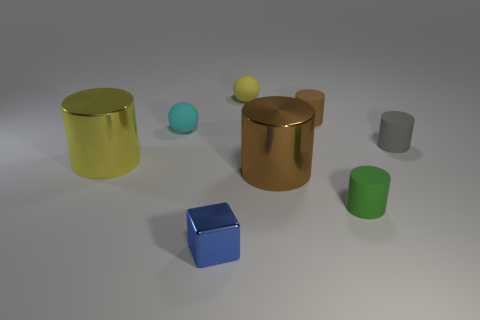How big is the sphere behind the tiny matte cylinder that is on the left side of the matte thing in front of the tiny gray cylinder?
Provide a succinct answer. Small. What size is the cyan ball?
Your response must be concise. Small. Is there a small matte sphere that is behind the big metallic object that is in front of the big shiny object that is left of the yellow ball?
Offer a very short reply. Yes. How many tiny things are either yellow matte balls or cyan objects?
Offer a terse response. 2. Is there any other thing that is the same color as the tiny metallic object?
Keep it short and to the point. No. There is a brown object that is in front of the gray matte object; is it the same size as the yellow shiny cylinder?
Give a very brief answer. Yes. There is a tiny matte ball in front of the rubber ball right of the cube that is in front of the cyan sphere; what is its color?
Your answer should be very brief. Cyan. What is the color of the metal block?
Provide a succinct answer. Blue. Does the large cylinder to the right of the yellow metal thing have the same material as the yellow thing to the right of the tiny blue cube?
Your answer should be very brief. No. There is a green thing that is the same shape as the small brown rubber thing; what material is it?
Your answer should be compact. Rubber. 